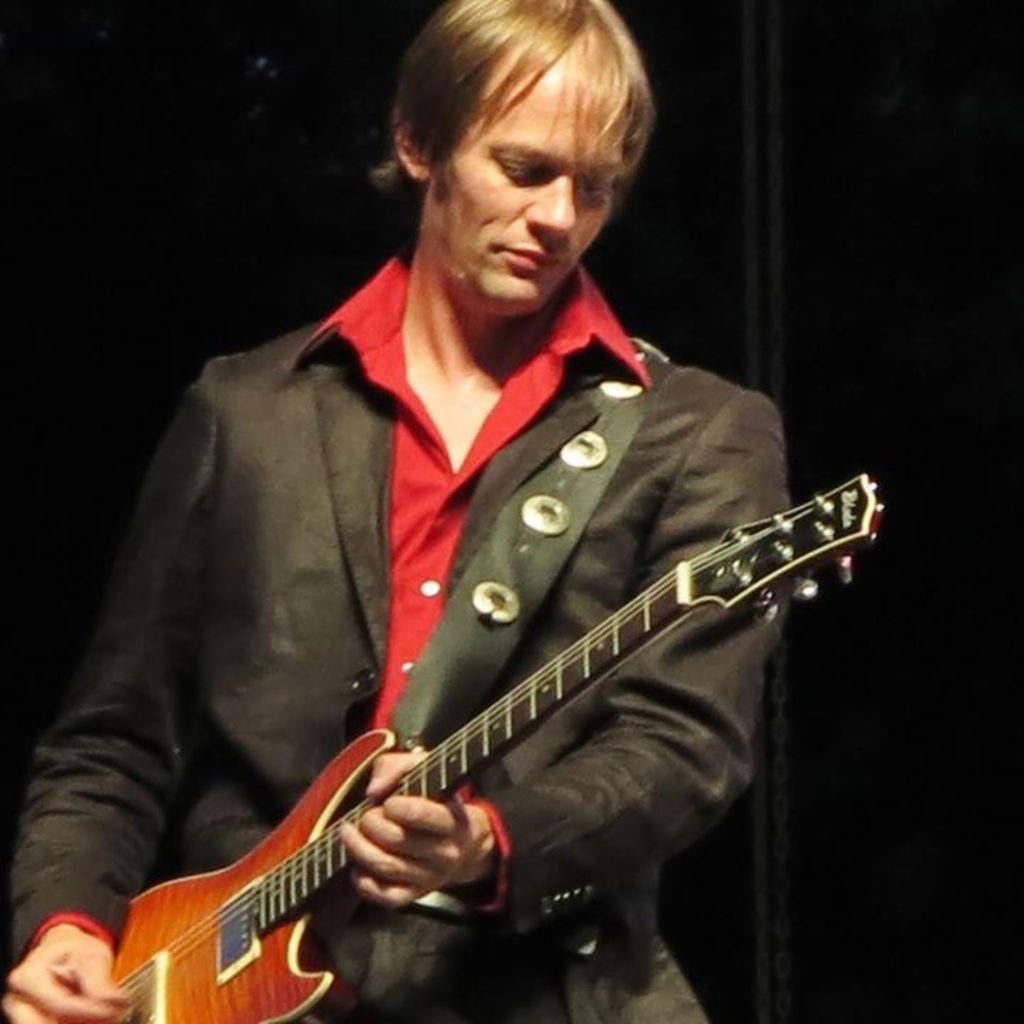What is the man in the image doing? The man is playing a guitar in the image. What is the man wearing? The man is wearing a black suit in the image. What part of the guitar is the man holding? The man has a strip of the guitar in the image. Are there any other objects or accessories visible in the image? Yes, there are badges in the image. How many kittens are sitting on the sidewalk next to the man in the image? There are no kittens or sidewalk present in the image; it features a man playing a guitar while wearing a black suit and holding a strip of the guitar. Can you see a giraffe in the background of the image? There is no giraffe visible in the image. 